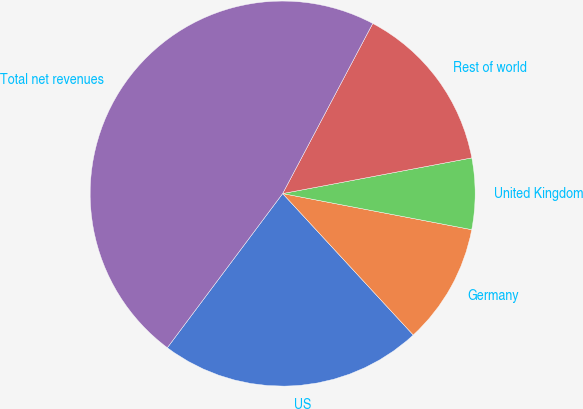Convert chart to OTSL. <chart><loc_0><loc_0><loc_500><loc_500><pie_chart><fcel>US<fcel>Germany<fcel>United Kingdom<fcel>Rest of world<fcel>Total net revenues<nl><fcel>22.09%<fcel>10.13%<fcel>5.97%<fcel>14.28%<fcel>47.53%<nl></chart> 